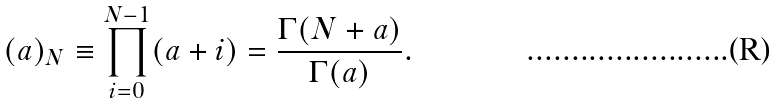<formula> <loc_0><loc_0><loc_500><loc_500>( a ) _ { N } \equiv \prod _ { i = 0 } ^ { N - 1 } ( a + i ) = \frac { \Gamma ( N + a ) } { \Gamma ( a ) } .</formula> 